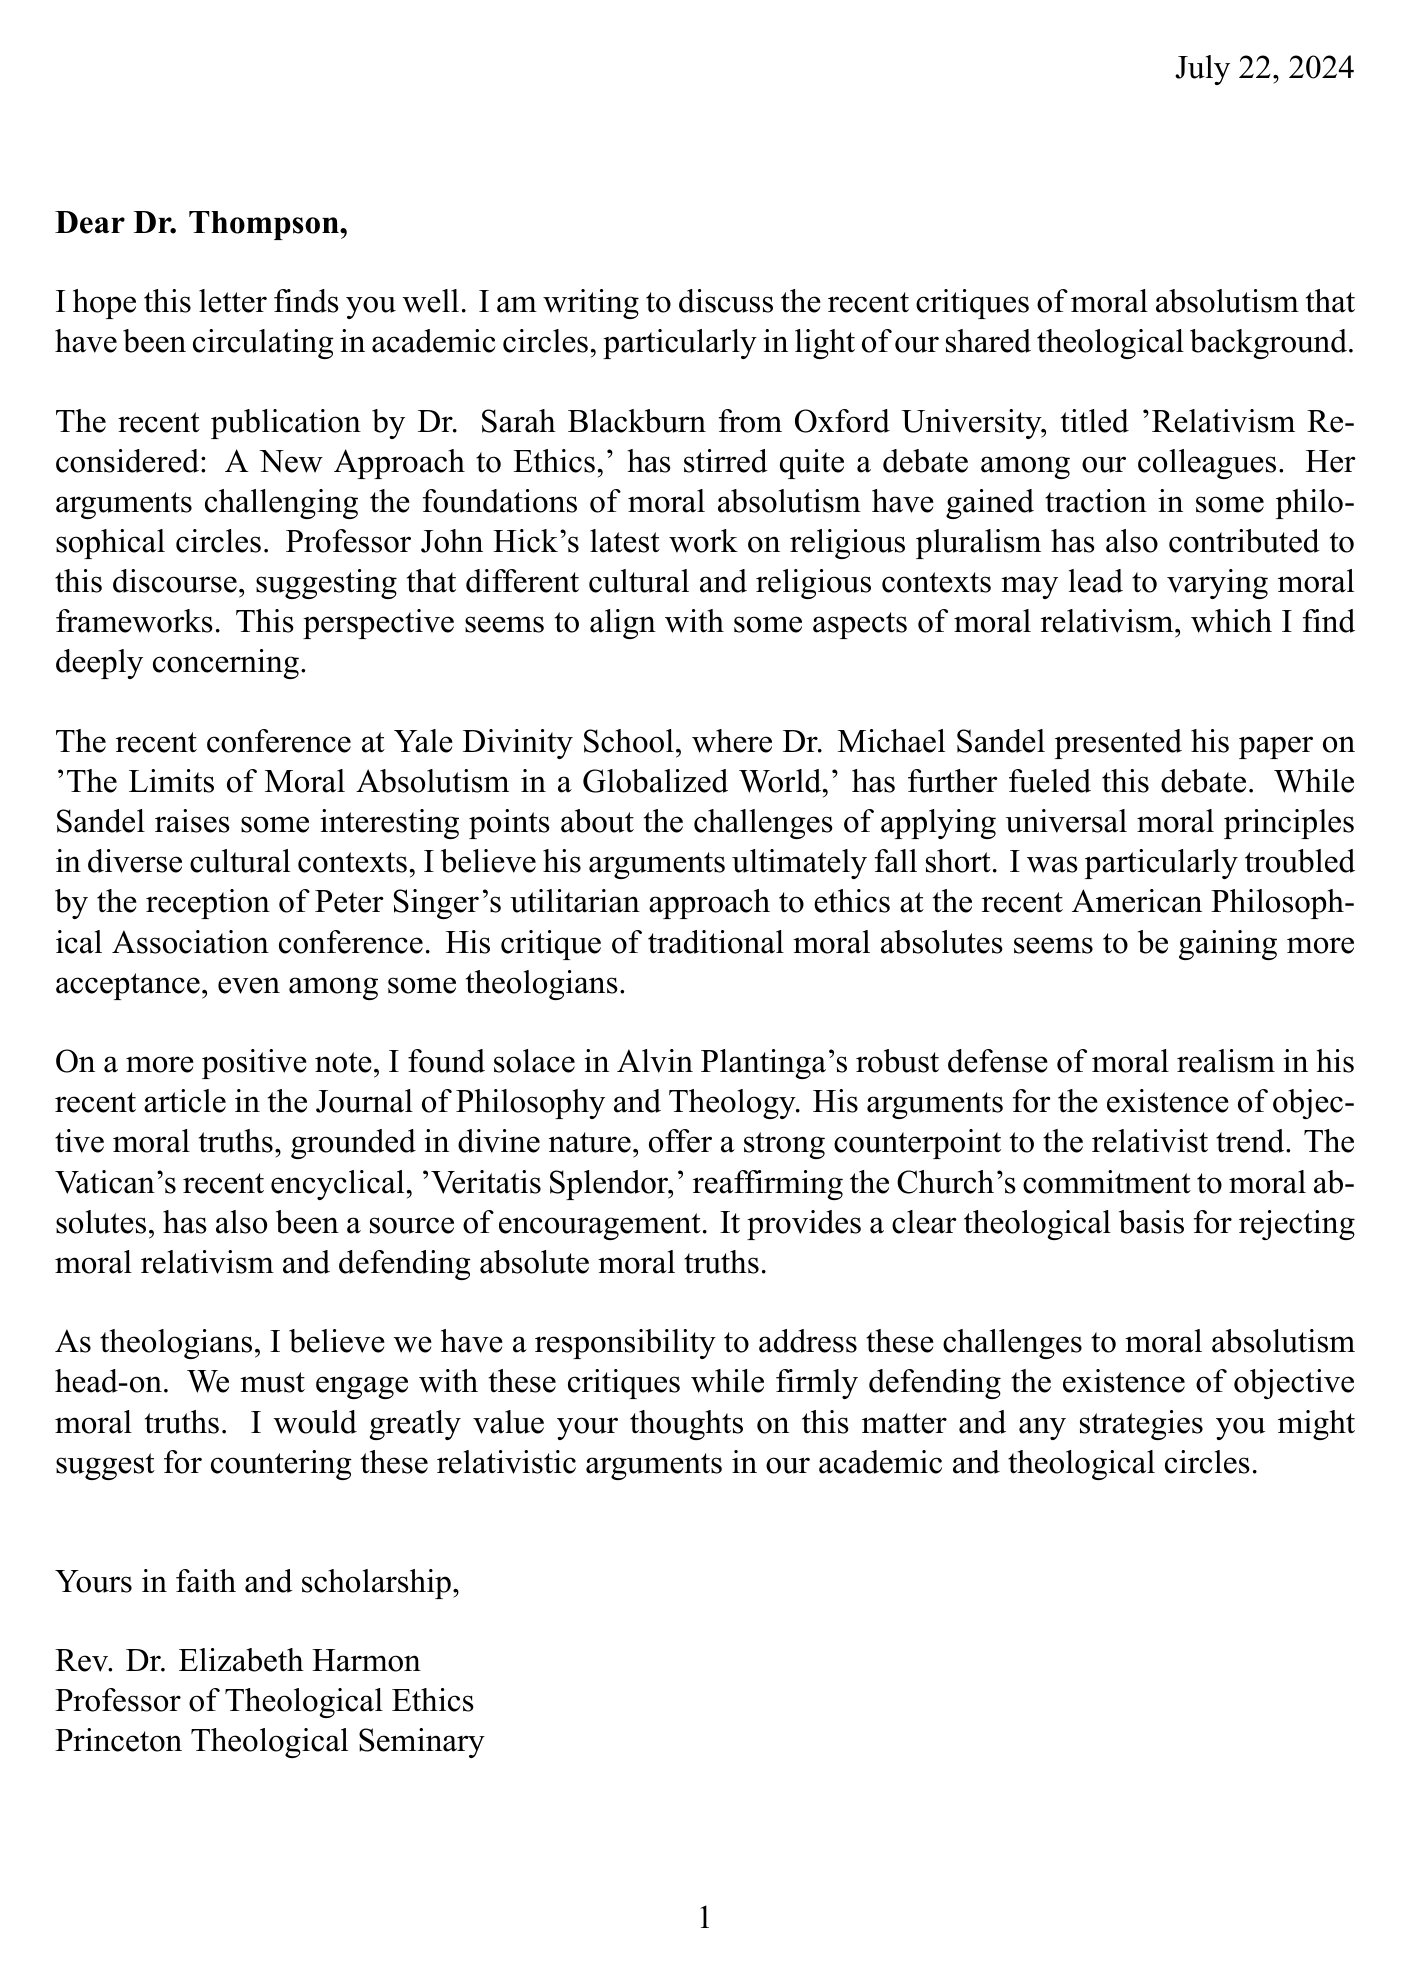What is the title of Dr. Sarah Blackburn's publication? The title of Dr. Sarah Blackburn's publication is mentioned in the letter as 'Relativism Reconsidered: A New Approach to Ethics.'
Answer: Relativism Reconsidered: A New Approach to Ethics Who presented a paper on 'The Limits of Moral Absolutism in a Globalized World'? The letter states that Dr. Michael Sandel presented a paper with this title at the Yale Divinity School conference.
Answer: Dr. Michael Sandel What is the recent Vatican encyclical mentioned in the letter? The letter mentions the encyclical 'Veritatis Splendor' as reaffirming the Church's commitment to moral absolutes.
Answer: Veritatis Splendor What philosophical approach is Peter Singer associated with in the letter? The letter describes Peter Singer's approach as utilitarian.
Answer: Utilitarian Which theologian's work offers a counterpoint to the relativist trend? The letter identifies Alvin Plantinga's work as a defense of moral realism that counters relativism.
Answer: Alvin Plantinga What is the primary concern of the author regarding moral relativism? The author expresses a deep concern about the acceptance of moral relativism in theological and academic discussions.
Answer: Deep concern What does the author hope to discuss with Dr. Thompson? The author hopes to discuss strategies for countering relativistic arguments in academic and theological circles.
Answer: Strategies for countering relativistic arguments Who is the author of the letter? The author of the letter is identified as Rev. Dr. Elizabeth Harmon.
Answer: Rev. Dr. Elizabeth Harmon 